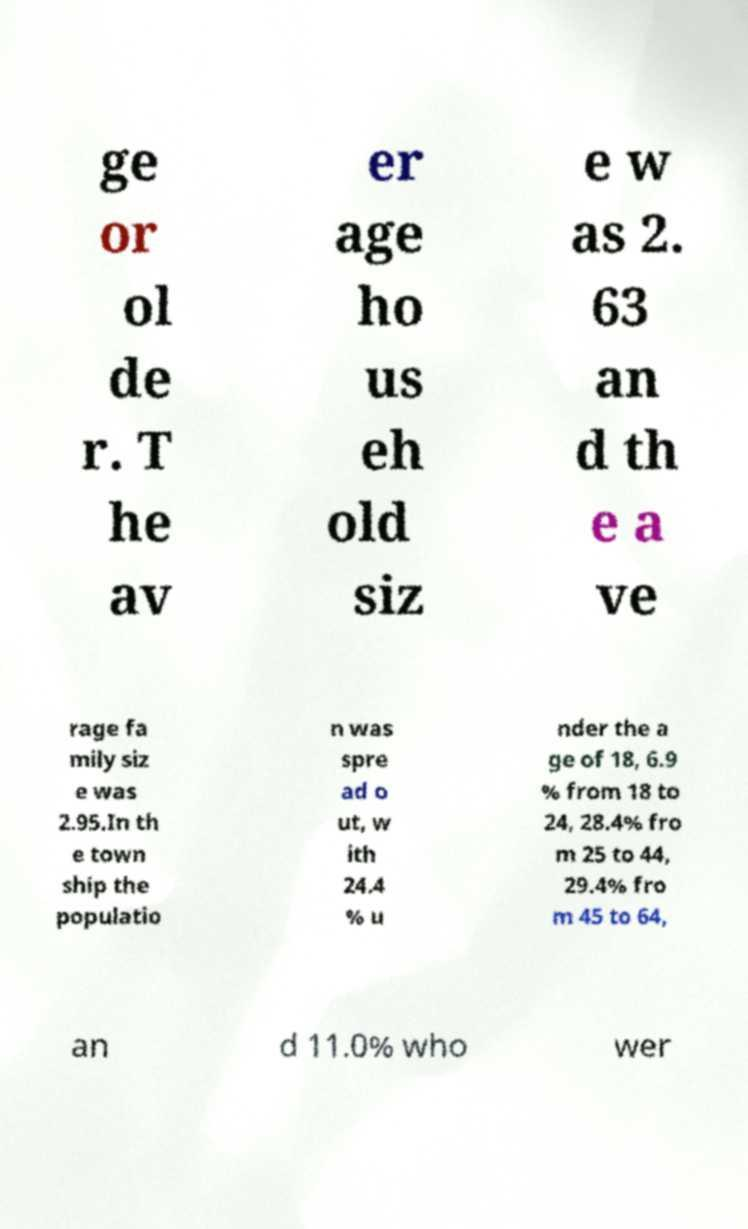Please read and relay the text visible in this image. What does it say? ge or ol de r. T he av er age ho us eh old siz e w as 2. 63 an d th e a ve rage fa mily siz e was 2.95.In th e town ship the populatio n was spre ad o ut, w ith 24.4 % u nder the a ge of 18, 6.9 % from 18 to 24, 28.4% fro m 25 to 44, 29.4% fro m 45 to 64, an d 11.0% who wer 